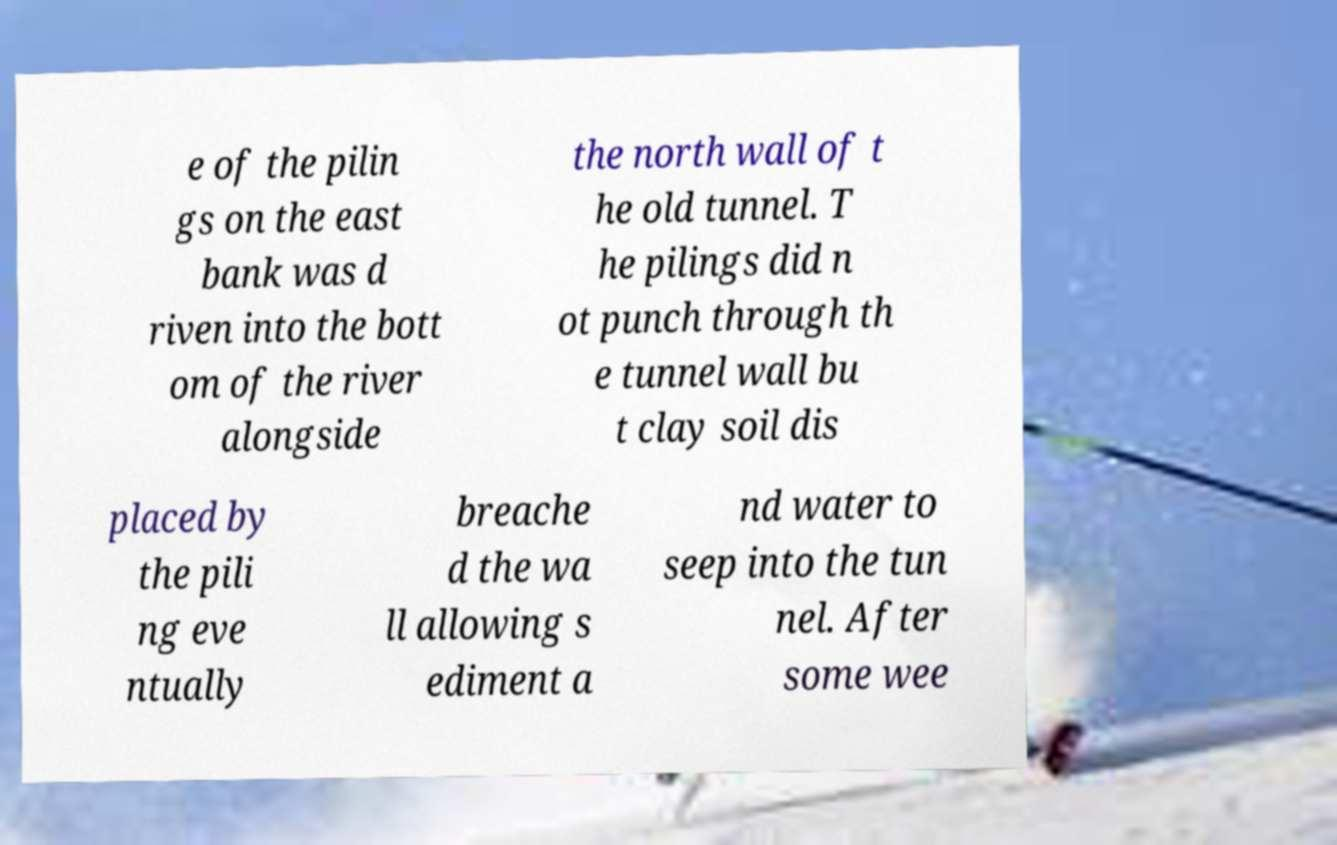I need the written content from this picture converted into text. Can you do that? e of the pilin gs on the east bank was d riven into the bott om of the river alongside the north wall of t he old tunnel. T he pilings did n ot punch through th e tunnel wall bu t clay soil dis placed by the pili ng eve ntually breache d the wa ll allowing s ediment a nd water to seep into the tun nel. After some wee 